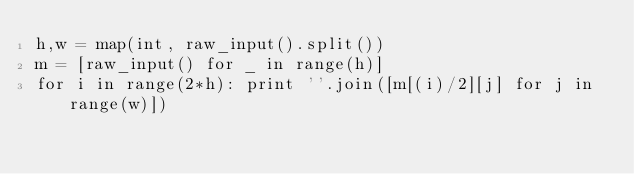Convert code to text. <code><loc_0><loc_0><loc_500><loc_500><_Python_>h,w = map(int, raw_input().split())
m = [raw_input() for _ in range(h)]
for i in range(2*h): print ''.join([m[(i)/2][j] for j in range(w)]) </code> 